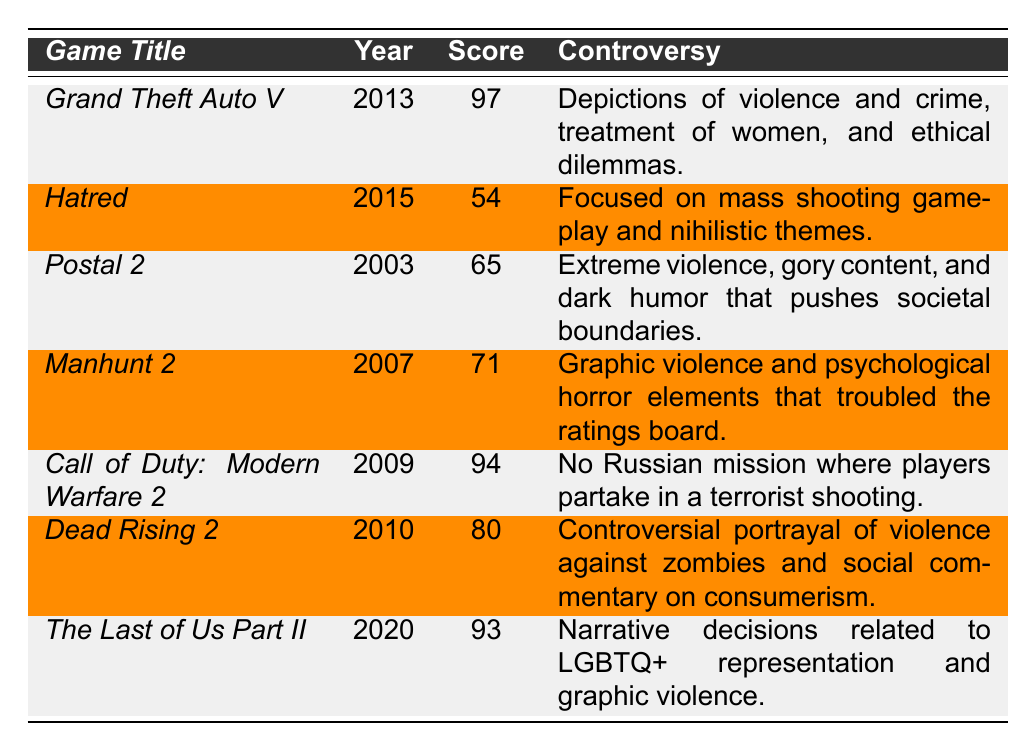What is the highest critic score among the listed games? The table shows the critic scores for each game. Scanning through the scores, *Grand Theft Auto V* has the highest score at 97.
Answer: 97 Which game was released in 2015? The table lists the games along with their release years. *Hatred* is the game that was released in 2015.
Answer: Hatred What is the average critic score of the games listed? To find the average, sum the critic scores: (97 + 54 + 65 + 71 + 94 + 80 + 93) = 554. There are 7 games, so the average is 554 / 7 ≈ 79.14.
Answer: Approximately 79.14 Is *The Last of Us Part II* associated with LGBTQ+ representation in its controversy? The controversy for *The Last of Us Part II* mentions narrative decisions related to LGBTQ+ representation, confirming the fact.
Answer: Yes What is the difference in critic scores between *Call of Duty: Modern Warfare 2* and *Hatred*? The score for *Call of Duty: Modern Warfare 2* is 94, and for *Hatred*, it is 54. The difference is 94 - 54 = 40.
Answer: 40 Which game has the lowest critic score, and what is that score? Analyzing the scores in the table, *Hatred* has the lowest score at 54.
Answer: Hatred, 54 How many games have a critic score above 90? From the table, the games with scores above 90 are *Grand Theft Auto V* (97), *Call of Duty: Modern Warfare 2* (94), and *The Last of Us Part II* (93). There are 3 games in total.
Answer: 3 Which two games have a score difference of more than 20 points? Looking at the scores, the difference between *Grand Theft Auto V* (97) and *Hatred* (54) is 43, which is more than 20. Additionally, *Call of Duty: Modern Warfare 2* (94) and *Hatred* (54) have a difference of 40, which also exceeds 20 points.
Answer: *Grand Theft Auto V* and *Hatred*; *Call of Duty: Modern Warfare 2* and *Hatred* Does *Dead Rising 2* criticize consumerism according to its listed controversy? The controversy for *Dead Rising 2* mentions a social commentary on consumerism, indicating that it does criticize consumerism.
Answer: Yes What is the combined score of *Manhunt 2* and *Postal 2*? The score for *Manhunt 2* is 71, and for *Postal 2*, it is 65. Their combined score is 71 + 65 = 136.
Answer: 136 